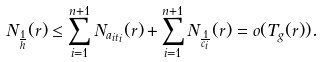<formula> <loc_0><loc_0><loc_500><loc_500>N _ { \frac { 1 } { h } } ( r ) \leq \sum _ { i = 1 } ^ { n + 1 } N _ { a _ { i t _ { i } } } ( r ) + \sum _ { i = 1 } ^ { n + 1 } N _ { \frac { 1 } { c _ { i } } } ( r ) = o ( T _ { g } ( r ) ) .</formula> 